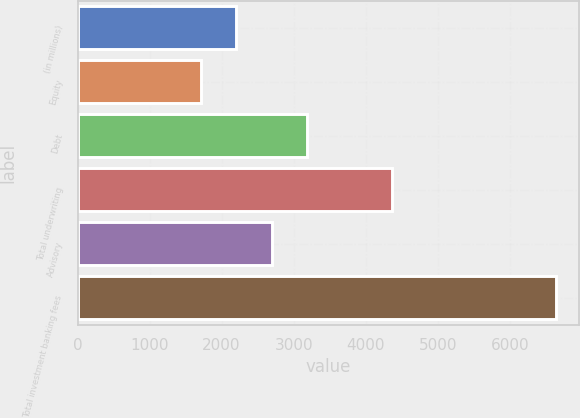Convert chart. <chart><loc_0><loc_0><loc_500><loc_500><bar_chart><fcel>(in millions)<fcel>Equity<fcel>Debt<fcel>Total underwriting<fcel>Advisory<fcel>Total investment banking fees<nl><fcel>2205.2<fcel>1713<fcel>3189.6<fcel>4363<fcel>2697.4<fcel>6635<nl></chart> 